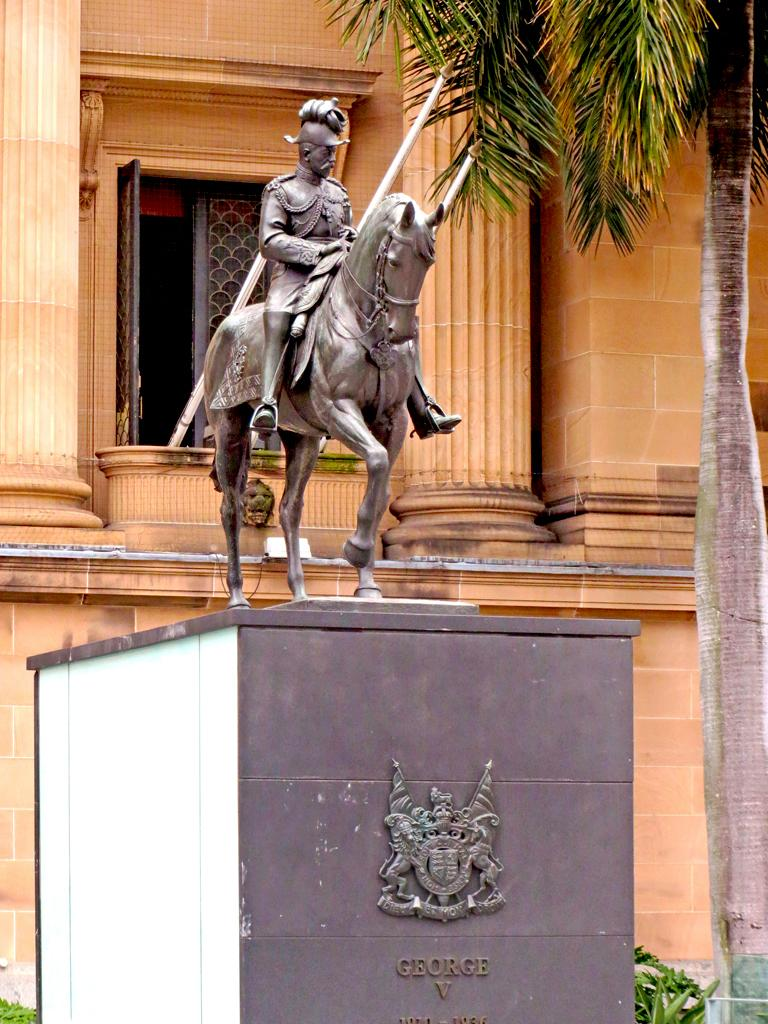What is the main subject of the image? There is a statue of a horse in the image. Are there any people in the image? Yes, there is a person in the image. What can be seen in the background of the image? There is a wall and a window in the background of the image. What type of creature is the person holding in the image? There is no creature present in the image; it features a statue of a horse and a person. What advice might the person's mom give them in the image? There is no reference to the person's mom in the image, so it's not possible to determine what advice she might give. 